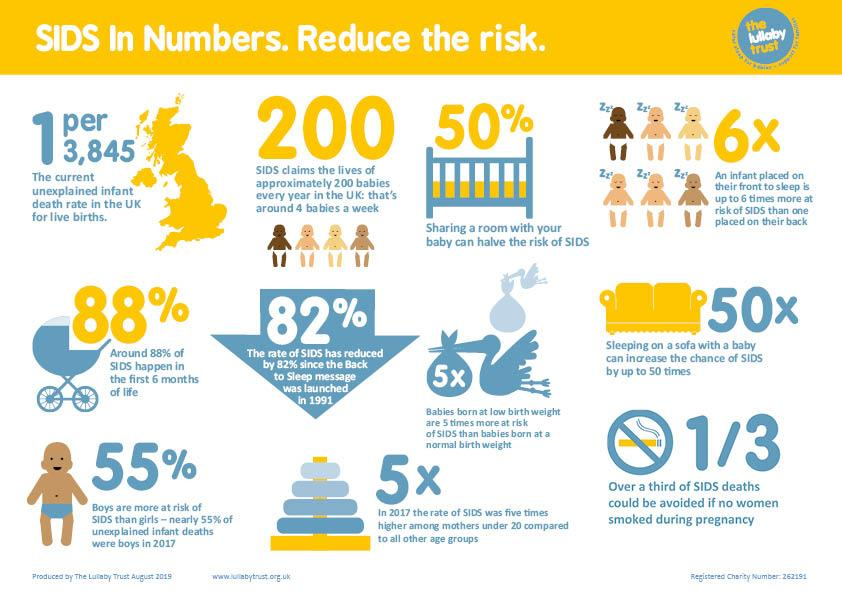Point out several critical features in this image. According to a study, sharing a room with a baby has been shown to decrease the risk of Sudden Infant Death Syndrome (SIDS) by 50%. The current unexplained infant death rate in the UK for live births is 1 death per 3,845 live births. According to statistics in the UK, approximately 88% of Sudden Infant Death Syndrome (SIDS) cases occur within the first 6 months of an infant's life. The rate of SIDS (Sudden Infant Death Syndrome) has decreased by 82% since the back to sleep message was launched in the UK in 1991. In the United Kingdom, an approximate of 200 babies lose their lives due to Sudden Infant Death Syndrome (SIDS) each year. 